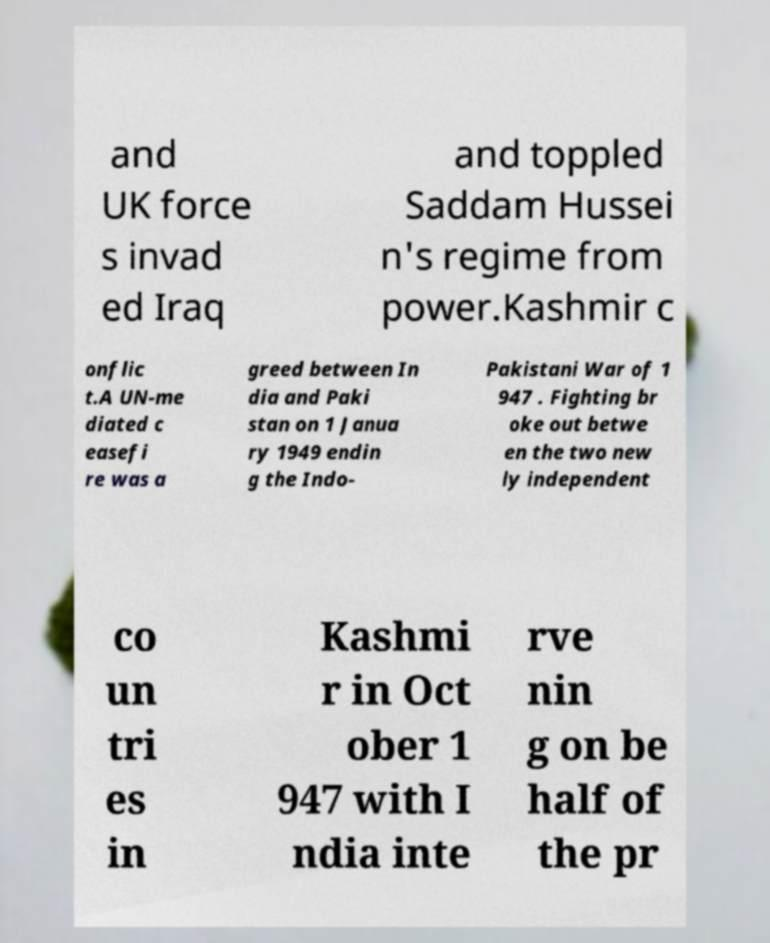For documentation purposes, I need the text within this image transcribed. Could you provide that? and UK force s invad ed Iraq and toppled Saddam Hussei n's regime from power.Kashmir c onflic t.A UN-me diated c easefi re was a greed between In dia and Paki stan on 1 Janua ry 1949 endin g the Indo- Pakistani War of 1 947 . Fighting br oke out betwe en the two new ly independent co un tri es in Kashmi r in Oct ober 1 947 with I ndia inte rve nin g on be half of the pr 